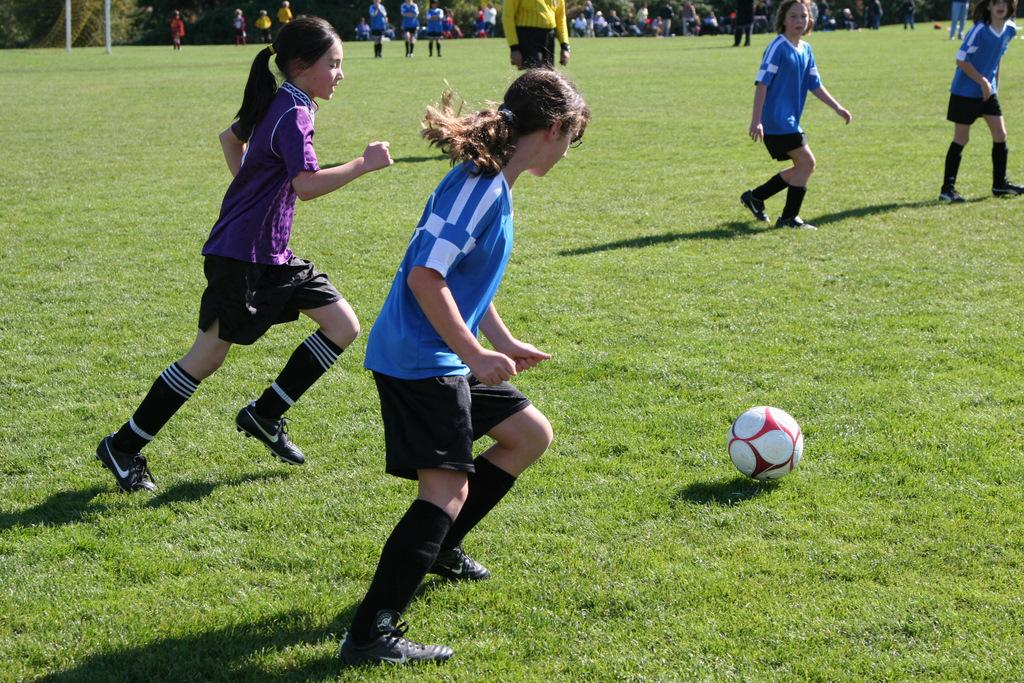What are the persons in the image wearing? The persons in the image are wearing clothes. What activity are some of the persons engaged in? Some persons are playing football. What type of surface is the football game being played on? There is grass on the ground. What is the main object being used in the football game? There is a football in the middle of the image. What type of government is depicted in the image? There is no depiction of a government in the image; it features persons playing football on a grassy surface. Can you tell me how many pets are present in the image? There are no pets present in the image; it features persons playing football on a grassy surface. 